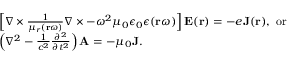<formula> <loc_0><loc_0><loc_500><loc_500>\begin{array} { r l } & { \left [ \nabla \times \frac { 1 } { \mu _ { r } ( r \omega ) } \nabla \times - \omega ^ { 2 } \mu _ { 0 } \epsilon _ { 0 } \epsilon ( r \omega ) \right ] E ( r ) = - e J ( r ) , o r } \\ & { \left ( \nabla ^ { 2 } - \frac { 1 } { c ^ { 2 } } \frac { \partial ^ { 2 } } { \partial t ^ { 2 } } \right ) A = - \mu _ { 0 } J . } \end{array}</formula> 